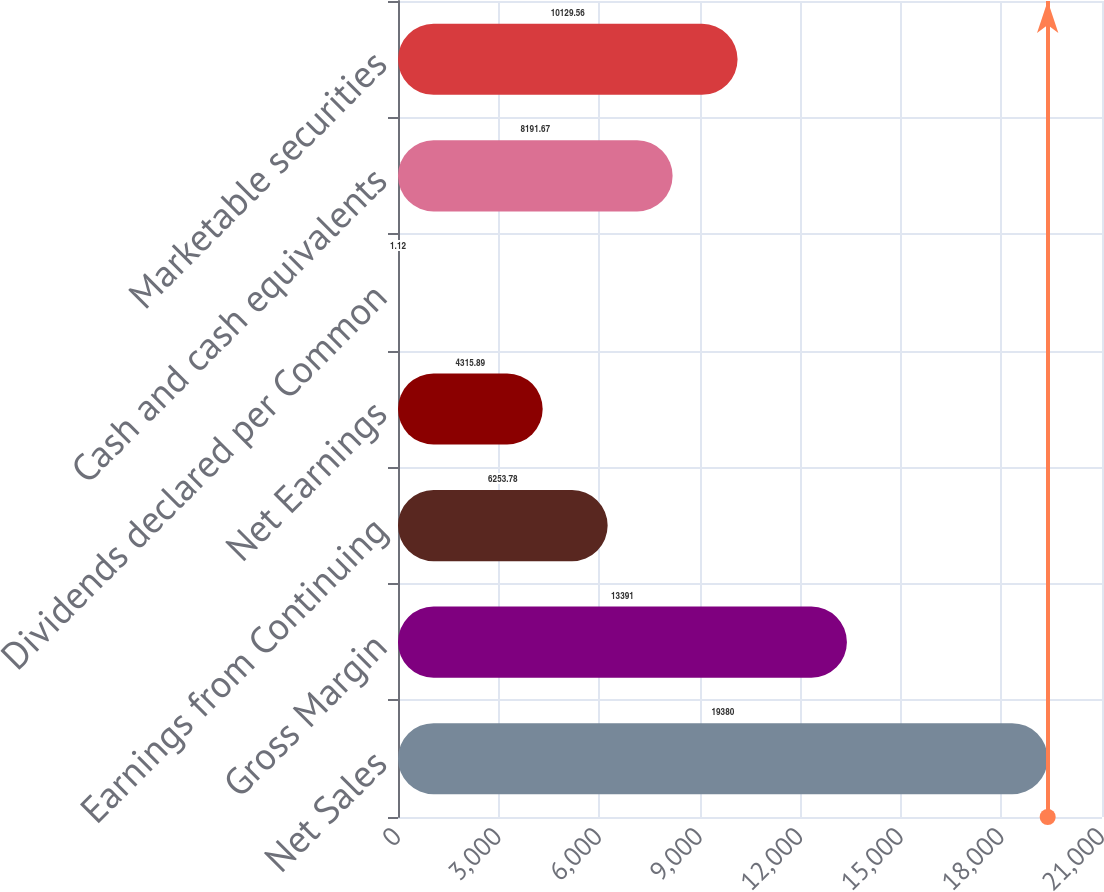<chart> <loc_0><loc_0><loc_500><loc_500><bar_chart><fcel>Net Sales<fcel>Gross Margin<fcel>Earnings from Continuing<fcel>Net Earnings<fcel>Dividends declared per Common<fcel>Cash and cash equivalents<fcel>Marketable securities<nl><fcel>19380<fcel>13391<fcel>6253.78<fcel>4315.89<fcel>1.12<fcel>8191.67<fcel>10129.6<nl></chart> 